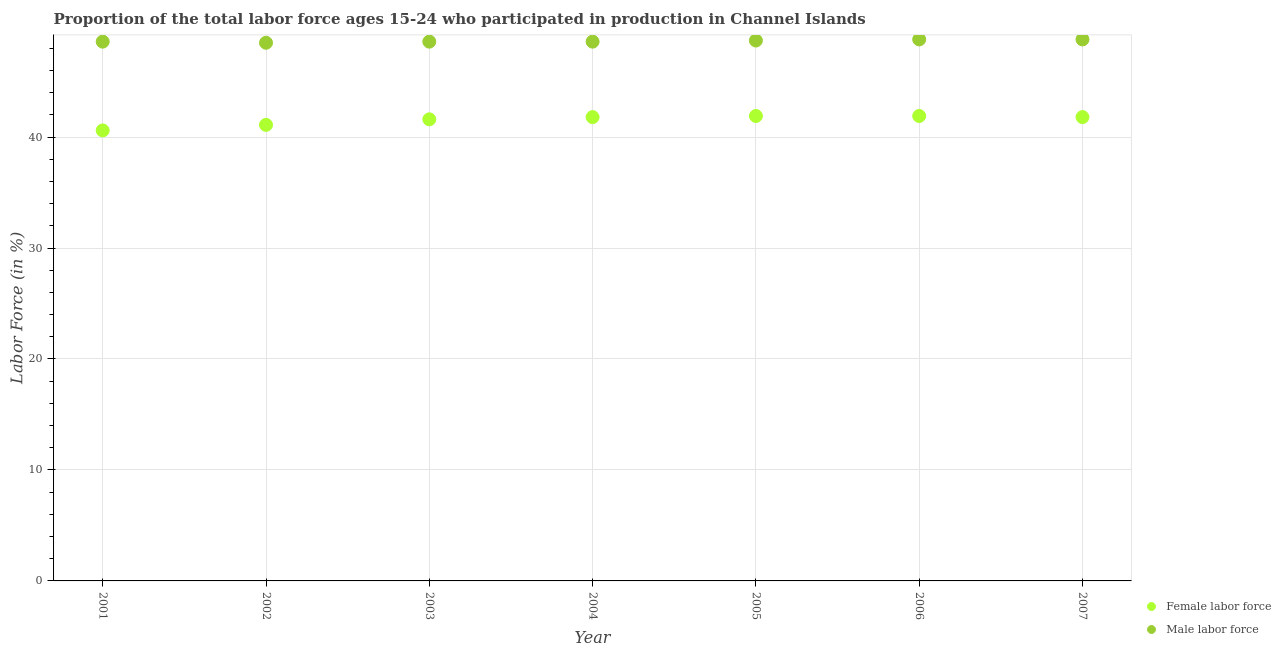How many different coloured dotlines are there?
Your answer should be compact. 2. What is the percentage of female labor force in 2006?
Offer a very short reply. 41.9. Across all years, what is the maximum percentage of female labor force?
Offer a terse response. 41.9. Across all years, what is the minimum percentage of male labour force?
Your answer should be compact. 48.5. In which year was the percentage of male labour force minimum?
Your answer should be compact. 2002. What is the total percentage of male labour force in the graph?
Keep it short and to the point. 340.6. What is the difference between the percentage of male labour force in 2001 and that in 2002?
Ensure brevity in your answer.  0.1. What is the difference between the percentage of male labour force in 2007 and the percentage of female labor force in 2005?
Keep it short and to the point. 6.9. What is the average percentage of male labour force per year?
Give a very brief answer. 48.66. In the year 2002, what is the difference between the percentage of male labour force and percentage of female labor force?
Your answer should be compact. 7.4. What is the ratio of the percentage of female labor force in 2006 to that in 2007?
Provide a succinct answer. 1. What is the difference between the highest and the second highest percentage of male labour force?
Your response must be concise. 0. What is the difference between the highest and the lowest percentage of male labour force?
Give a very brief answer. 0.3. In how many years, is the percentage of male labour force greater than the average percentage of male labour force taken over all years?
Your response must be concise. 3. Is the percentage of female labor force strictly greater than the percentage of male labour force over the years?
Your answer should be very brief. No. Is the percentage of male labour force strictly less than the percentage of female labor force over the years?
Offer a very short reply. No. How many dotlines are there?
Your answer should be very brief. 2. What is the difference between two consecutive major ticks on the Y-axis?
Your answer should be compact. 10. Does the graph contain grids?
Your answer should be very brief. Yes. How are the legend labels stacked?
Provide a short and direct response. Vertical. What is the title of the graph?
Your response must be concise. Proportion of the total labor force ages 15-24 who participated in production in Channel Islands. Does "RDB concessional" appear as one of the legend labels in the graph?
Your response must be concise. No. What is the label or title of the Y-axis?
Provide a succinct answer. Labor Force (in %). What is the Labor Force (in %) in Female labor force in 2001?
Provide a succinct answer. 40.6. What is the Labor Force (in %) in Male labor force in 2001?
Your answer should be compact. 48.6. What is the Labor Force (in %) of Female labor force in 2002?
Your answer should be compact. 41.1. What is the Labor Force (in %) of Male labor force in 2002?
Ensure brevity in your answer.  48.5. What is the Labor Force (in %) of Female labor force in 2003?
Your answer should be very brief. 41.6. What is the Labor Force (in %) in Male labor force in 2003?
Ensure brevity in your answer.  48.6. What is the Labor Force (in %) of Female labor force in 2004?
Offer a terse response. 41.8. What is the Labor Force (in %) in Male labor force in 2004?
Your response must be concise. 48.6. What is the Labor Force (in %) of Female labor force in 2005?
Ensure brevity in your answer.  41.9. What is the Labor Force (in %) in Male labor force in 2005?
Offer a terse response. 48.7. What is the Labor Force (in %) in Female labor force in 2006?
Your response must be concise. 41.9. What is the Labor Force (in %) in Male labor force in 2006?
Make the answer very short. 48.8. What is the Labor Force (in %) of Female labor force in 2007?
Keep it short and to the point. 41.8. What is the Labor Force (in %) of Male labor force in 2007?
Offer a very short reply. 48.8. Across all years, what is the maximum Labor Force (in %) in Female labor force?
Give a very brief answer. 41.9. Across all years, what is the maximum Labor Force (in %) in Male labor force?
Make the answer very short. 48.8. Across all years, what is the minimum Labor Force (in %) in Female labor force?
Your response must be concise. 40.6. Across all years, what is the minimum Labor Force (in %) in Male labor force?
Offer a very short reply. 48.5. What is the total Labor Force (in %) in Female labor force in the graph?
Your answer should be very brief. 290.7. What is the total Labor Force (in %) in Male labor force in the graph?
Keep it short and to the point. 340.6. What is the difference between the Labor Force (in %) of Male labor force in 2001 and that in 2002?
Your response must be concise. 0.1. What is the difference between the Labor Force (in %) in Male labor force in 2001 and that in 2003?
Your answer should be compact. 0. What is the difference between the Labor Force (in %) in Male labor force in 2001 and that in 2004?
Offer a very short reply. 0. What is the difference between the Labor Force (in %) in Female labor force in 2001 and that in 2005?
Offer a very short reply. -1.3. What is the difference between the Labor Force (in %) of Female labor force in 2002 and that in 2003?
Make the answer very short. -0.5. What is the difference between the Labor Force (in %) of Male labor force in 2002 and that in 2003?
Your response must be concise. -0.1. What is the difference between the Labor Force (in %) of Female labor force in 2002 and that in 2004?
Ensure brevity in your answer.  -0.7. What is the difference between the Labor Force (in %) in Male labor force in 2002 and that in 2004?
Make the answer very short. -0.1. What is the difference between the Labor Force (in %) of Female labor force in 2002 and that in 2005?
Your answer should be very brief. -0.8. What is the difference between the Labor Force (in %) of Male labor force in 2002 and that in 2005?
Make the answer very short. -0.2. What is the difference between the Labor Force (in %) in Male labor force in 2002 and that in 2007?
Provide a short and direct response. -0.3. What is the difference between the Labor Force (in %) in Female labor force in 2003 and that in 2004?
Provide a succinct answer. -0.2. What is the difference between the Labor Force (in %) of Male labor force in 2003 and that in 2005?
Ensure brevity in your answer.  -0.1. What is the difference between the Labor Force (in %) in Female labor force in 2003 and that in 2006?
Ensure brevity in your answer.  -0.3. What is the difference between the Labor Force (in %) of Male labor force in 2003 and that in 2006?
Give a very brief answer. -0.2. What is the difference between the Labor Force (in %) in Female labor force in 2003 and that in 2007?
Your answer should be compact. -0.2. What is the difference between the Labor Force (in %) in Male labor force in 2003 and that in 2007?
Your response must be concise. -0.2. What is the difference between the Labor Force (in %) of Female labor force in 2004 and that in 2005?
Provide a short and direct response. -0.1. What is the difference between the Labor Force (in %) of Male labor force in 2004 and that in 2005?
Ensure brevity in your answer.  -0.1. What is the difference between the Labor Force (in %) of Female labor force in 2004 and that in 2006?
Provide a succinct answer. -0.1. What is the difference between the Labor Force (in %) in Male labor force in 2004 and that in 2006?
Provide a succinct answer. -0.2. What is the difference between the Labor Force (in %) in Female labor force in 2004 and that in 2007?
Keep it short and to the point. 0. What is the difference between the Labor Force (in %) of Male labor force in 2004 and that in 2007?
Provide a succinct answer. -0.2. What is the difference between the Labor Force (in %) of Female labor force in 2005 and that in 2006?
Provide a succinct answer. 0. What is the difference between the Labor Force (in %) of Female labor force in 2006 and that in 2007?
Your answer should be compact. 0.1. What is the difference between the Labor Force (in %) in Female labor force in 2001 and the Labor Force (in %) in Male labor force in 2002?
Provide a succinct answer. -7.9. What is the difference between the Labor Force (in %) in Female labor force in 2001 and the Labor Force (in %) in Male labor force in 2003?
Make the answer very short. -8. What is the difference between the Labor Force (in %) in Female labor force in 2001 and the Labor Force (in %) in Male labor force in 2006?
Provide a succinct answer. -8.2. What is the difference between the Labor Force (in %) in Female labor force in 2002 and the Labor Force (in %) in Male labor force in 2003?
Offer a very short reply. -7.5. What is the difference between the Labor Force (in %) of Female labor force in 2002 and the Labor Force (in %) of Male labor force in 2004?
Your response must be concise. -7.5. What is the difference between the Labor Force (in %) of Female labor force in 2003 and the Labor Force (in %) of Male labor force in 2005?
Offer a terse response. -7.1. What is the difference between the Labor Force (in %) of Female labor force in 2003 and the Labor Force (in %) of Male labor force in 2006?
Offer a very short reply. -7.2. What is the difference between the Labor Force (in %) of Female labor force in 2003 and the Labor Force (in %) of Male labor force in 2007?
Offer a very short reply. -7.2. What is the difference between the Labor Force (in %) of Female labor force in 2004 and the Labor Force (in %) of Male labor force in 2005?
Provide a succinct answer. -6.9. What is the difference between the Labor Force (in %) of Female labor force in 2004 and the Labor Force (in %) of Male labor force in 2006?
Ensure brevity in your answer.  -7. What is the average Labor Force (in %) of Female labor force per year?
Ensure brevity in your answer.  41.53. What is the average Labor Force (in %) in Male labor force per year?
Your response must be concise. 48.66. In the year 2001, what is the difference between the Labor Force (in %) in Female labor force and Labor Force (in %) in Male labor force?
Your answer should be very brief. -8. In the year 2003, what is the difference between the Labor Force (in %) of Female labor force and Labor Force (in %) of Male labor force?
Offer a very short reply. -7. In the year 2007, what is the difference between the Labor Force (in %) of Female labor force and Labor Force (in %) of Male labor force?
Give a very brief answer. -7. What is the ratio of the Labor Force (in %) of Female labor force in 2001 to that in 2002?
Give a very brief answer. 0.99. What is the ratio of the Labor Force (in %) of Male labor force in 2001 to that in 2002?
Offer a very short reply. 1. What is the ratio of the Labor Force (in %) in Male labor force in 2001 to that in 2003?
Make the answer very short. 1. What is the ratio of the Labor Force (in %) in Female labor force in 2001 to that in 2004?
Give a very brief answer. 0.97. What is the ratio of the Labor Force (in %) of Female labor force in 2001 to that in 2006?
Provide a succinct answer. 0.97. What is the ratio of the Labor Force (in %) in Female labor force in 2001 to that in 2007?
Give a very brief answer. 0.97. What is the ratio of the Labor Force (in %) of Female labor force in 2002 to that in 2003?
Your answer should be very brief. 0.99. What is the ratio of the Labor Force (in %) in Male labor force in 2002 to that in 2003?
Your answer should be very brief. 1. What is the ratio of the Labor Force (in %) in Female labor force in 2002 to that in 2004?
Give a very brief answer. 0.98. What is the ratio of the Labor Force (in %) of Female labor force in 2002 to that in 2005?
Make the answer very short. 0.98. What is the ratio of the Labor Force (in %) of Male labor force in 2002 to that in 2005?
Keep it short and to the point. 1. What is the ratio of the Labor Force (in %) of Female labor force in 2002 to that in 2006?
Keep it short and to the point. 0.98. What is the ratio of the Labor Force (in %) in Female labor force in 2002 to that in 2007?
Your response must be concise. 0.98. What is the ratio of the Labor Force (in %) of Male labor force in 2002 to that in 2007?
Make the answer very short. 0.99. What is the ratio of the Labor Force (in %) in Female labor force in 2003 to that in 2006?
Provide a short and direct response. 0.99. What is the ratio of the Labor Force (in %) of Female labor force in 2004 to that in 2005?
Your answer should be very brief. 1. What is the ratio of the Labor Force (in %) of Male labor force in 2004 to that in 2005?
Ensure brevity in your answer.  1. What is the ratio of the Labor Force (in %) in Female labor force in 2004 to that in 2007?
Your response must be concise. 1. What is the ratio of the Labor Force (in %) of Male labor force in 2004 to that in 2007?
Make the answer very short. 1. What is the ratio of the Labor Force (in %) of Female labor force in 2005 to that in 2006?
Provide a short and direct response. 1. What is the ratio of the Labor Force (in %) in Male labor force in 2005 to that in 2006?
Provide a short and direct response. 1. What is the ratio of the Labor Force (in %) of Female labor force in 2005 to that in 2007?
Provide a short and direct response. 1. What is the ratio of the Labor Force (in %) in Male labor force in 2005 to that in 2007?
Give a very brief answer. 1. What is the ratio of the Labor Force (in %) of Female labor force in 2006 to that in 2007?
Your response must be concise. 1. What is the difference between the highest and the second highest Labor Force (in %) of Female labor force?
Your answer should be compact. 0. What is the difference between the highest and the second highest Labor Force (in %) in Male labor force?
Offer a very short reply. 0. What is the difference between the highest and the lowest Labor Force (in %) in Female labor force?
Your answer should be very brief. 1.3. 